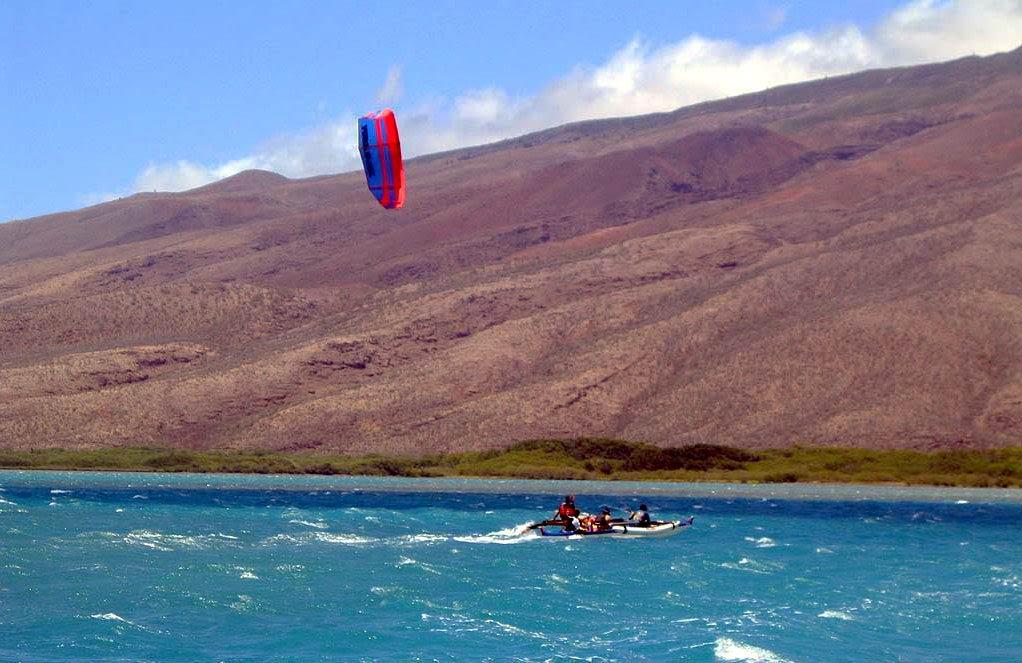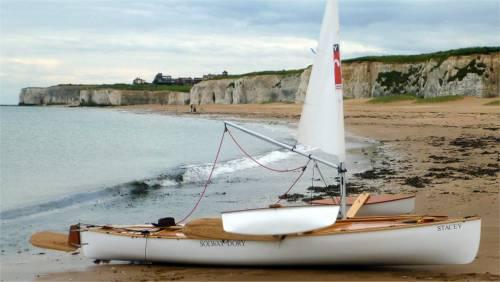The first image is the image on the left, the second image is the image on the right. Examine the images to the left and right. Is the description "One of the boats appears to have been grounded on the beach; the boat can easily be used again later." accurate? Answer yes or no. Yes. 